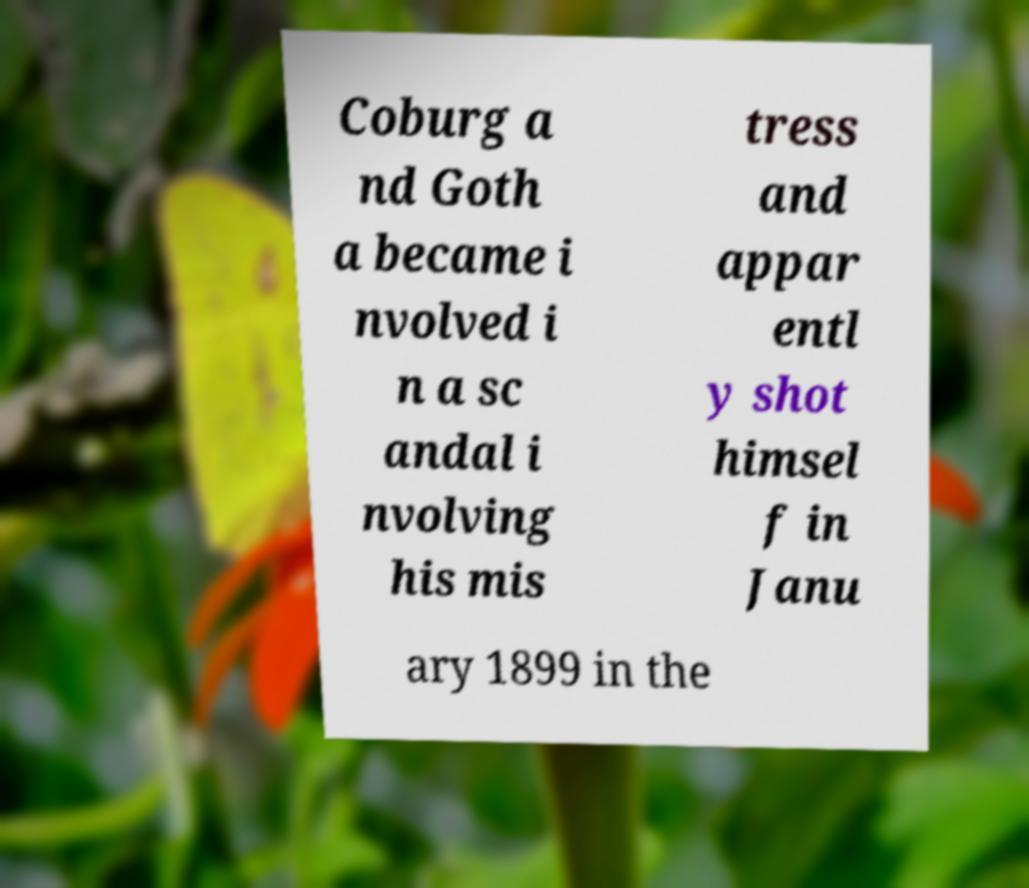Can you read and provide the text displayed in the image?This photo seems to have some interesting text. Can you extract and type it out for me? Coburg a nd Goth a became i nvolved i n a sc andal i nvolving his mis tress and appar entl y shot himsel f in Janu ary 1899 in the 